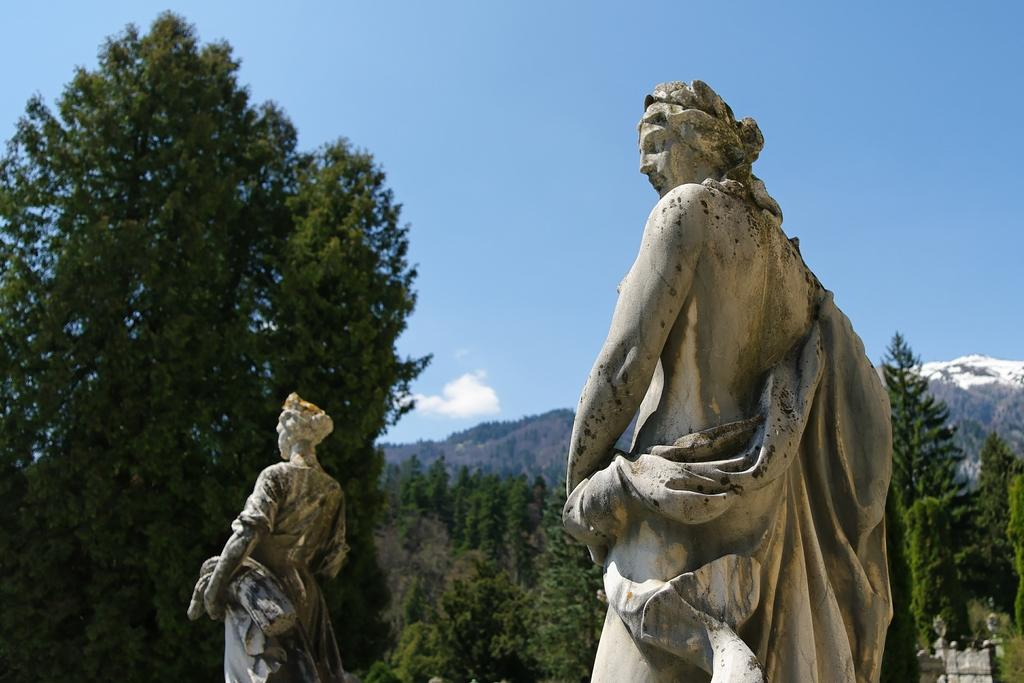What can be seen in the image that represents human figures? There are two statues of girls in the image. What type of natural landscape is visible in the background of the image? There are hills with trees in the background of the image. What is visible at the top of the image? The sky is visible at the top of the image. What type of silk is draped over the table in the image? There is no table or silk present in the image; it features two statues of girls and a natural landscape in the background. 